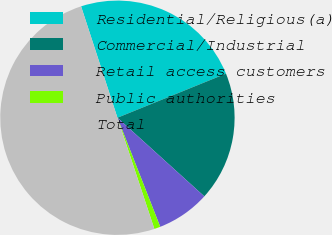Convert chart. <chart><loc_0><loc_0><loc_500><loc_500><pie_chart><fcel>Residential/Religious(a)<fcel>Commercial/Industrial<fcel>Retail access customers<fcel>Public authorities<fcel>Total<nl><fcel>23.88%<fcel>17.85%<fcel>7.34%<fcel>0.85%<fcel>50.08%<nl></chart> 